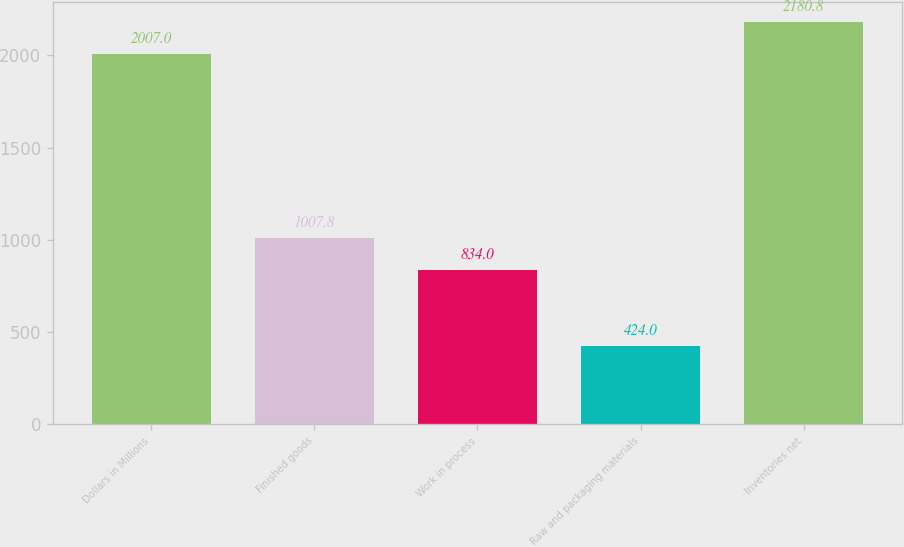<chart> <loc_0><loc_0><loc_500><loc_500><bar_chart><fcel>Dollars in Millions<fcel>Finished goods<fcel>Work in process<fcel>Raw and packaging materials<fcel>Inventories net<nl><fcel>2007<fcel>1007.8<fcel>834<fcel>424<fcel>2180.8<nl></chart> 